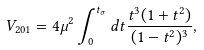<formula> <loc_0><loc_0><loc_500><loc_500>V _ { 2 0 1 } = 4 \mu ^ { 2 } \int _ { 0 } ^ { t _ { \sigma } } { d t } \frac { t ^ { 3 } ( 1 + t ^ { 2 } ) } { ( 1 - t ^ { 2 } ) ^ { 3 } } ,</formula> 